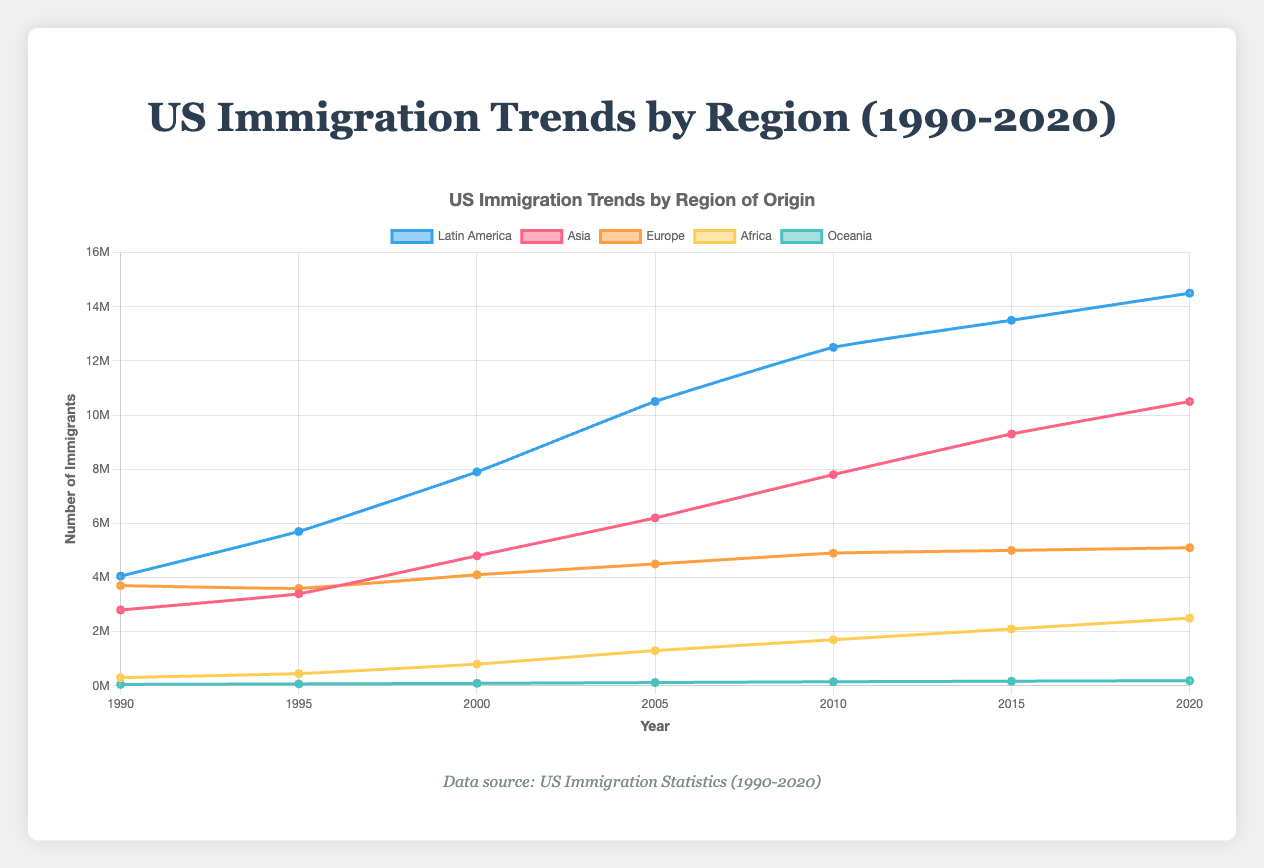Which region had the highest number of immigrants in 2020? By visually inspecting the final data points, Latin America has the highest value, represented by the highest line in 2020, which is 14,500,000 immigrants.
Answer: Latin America How did the number of immigrants from Africa change from 1990 to 2020? Start at 1990 and end at 2020, and see the values for Africa. In 1990, it was 300,000, and in 2020 it was 2,500,000. The number represents a substantial increase.
Answer: Increased from 300,000 to 2,500,000 Which two regions experienced the most growth in immigrants between 1990 and 2020? Calculate the difference for each region. Latin America: 14,500,000 - 4,050,000 = 10,450,000. Asia: 10,500,000 - 2,800,000 = 7,700,000. Europe: 5,100,000 - 3,700,000 = 1,400,000. Africa: 2,500,000 - 300,000 = 2,200,000. Oceania: 190,000 - 50,000 = 140,000. Latin America and Asia show the largest numbers.
Answer: Latin America and Asia What is the average number of immigrants from Europe over the years shown? Sum the values for Europe (3,700,000 + 3,600,000 + 4,100,000 + 4,500,000 + 4,900,000 + 5,000,000 + 5,100,000) = 30,900,000. Now divide by the number of years (7). 30,900,000 / 7 ≈ 4,414,286.
Answer: Approximately 4,414,286 In which year did Latin America surpass 10 million immigrants? By examining the line for Latin America, 2005 marks the first point above 10 million.
Answer: 2005 Compare the trend between Asia and Africa. Which region has a steeper increase rate? Identify the slope of the changes. Asia goes from 2,800,000 in 1990 to 10,500,000 in 2020, a change of 7,700,000. Africa goes from 300,000 in 1990 to 2,500,000 in 2020, a change of 2,200,000. Asia's change is much steeper.
Answer: Asia What is the percentage change in the number of immigrants from Oceania from 1990 to 2020? Change from 50,000 to 190,000 represents an increase of 140,000. Percentage change = (140,000 / 50,000) * 100 = 280%.
Answer: 280% Which region had the least number of immigrants in 2010, and what was the value? Inspect 2010's data points; Oceania has the lowest with 150,000 immigrants.
Answer: Oceania, 150,000 What is the total number of immigrants from all regions in 2000? Sum the values for 2000 (Latin America: 7,900,000, Asia: 4,800,000, Europe: 4,100,000, Africa: 800,000, Oceania: 90,000). Total = 7,900,000 + 4,800,000 + 4,100,000 + 800,000 + 90,000 = 17,690,000.
Answer: 17,690,000 During which decade did Asia see the largest growth in the number of immigrants? Compare the difference in each decade. 1990-2000: 2,000,000, 2000-2010: 3,000,000, 2010-2020: 2,700,000. The largest growth was between 2000 and 2010.
Answer: 2000-2010 